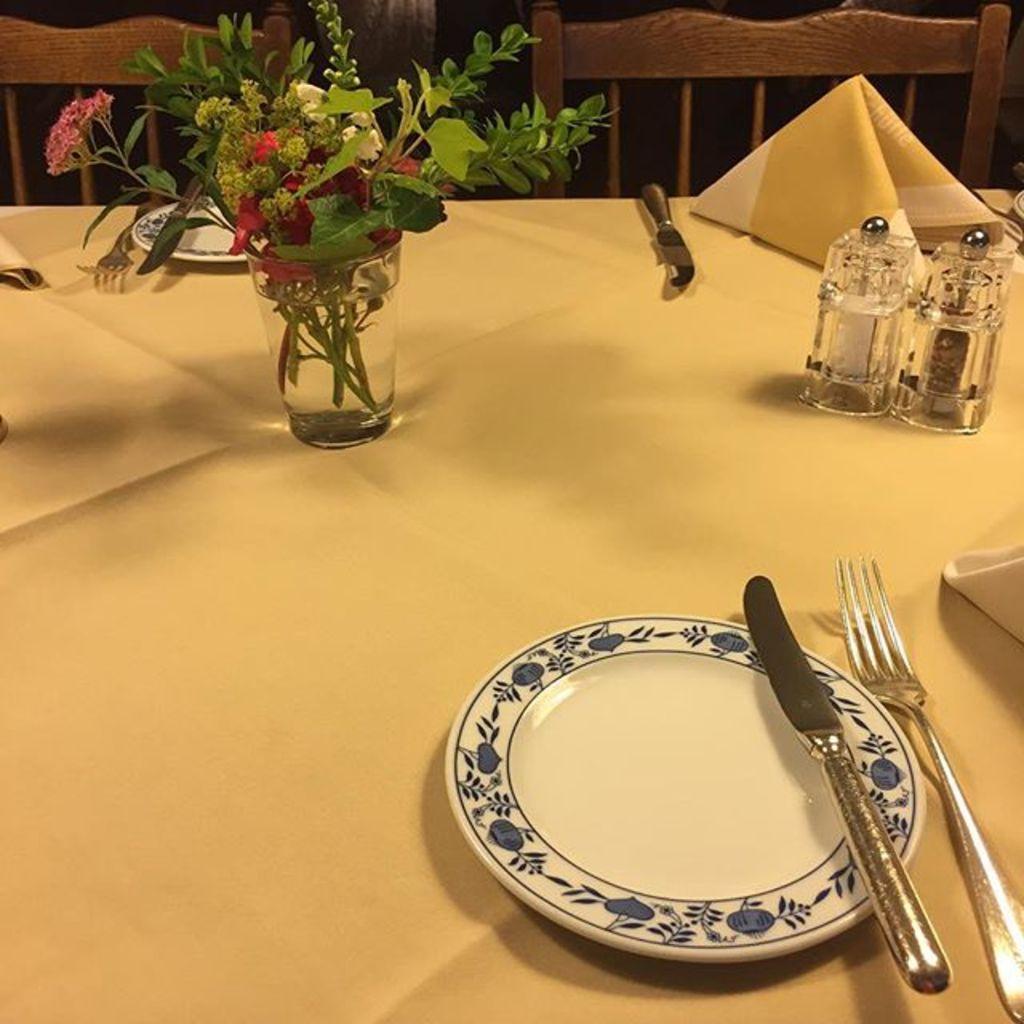Describe this image in one or two sentences. Here I can see a table covered with a cloth. On the table a glass, plates, spoons, napkins and some other other objects are placed. At the top there are two chairs. 